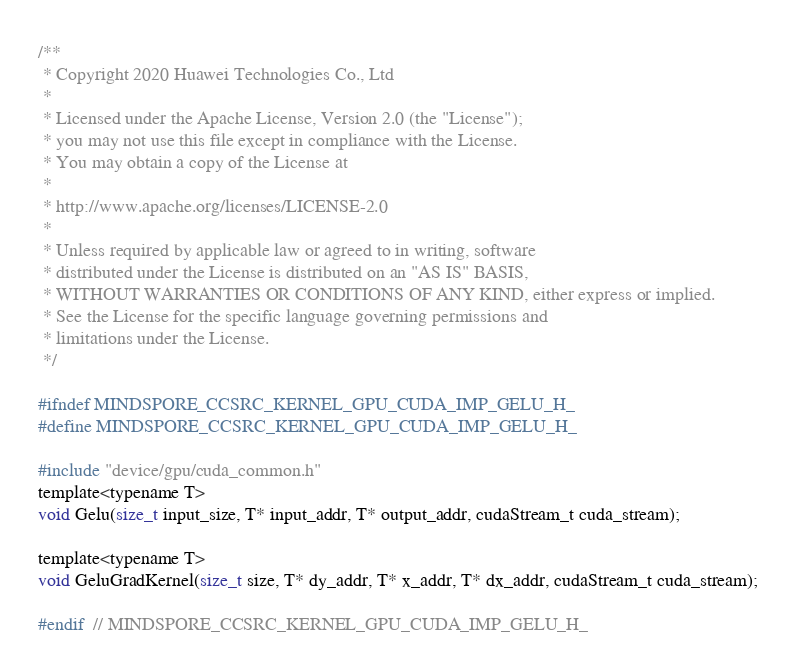Convert code to text. <code><loc_0><loc_0><loc_500><loc_500><_Cuda_>/**
 * Copyright 2020 Huawei Technologies Co., Ltd
 *
 * Licensed under the Apache License, Version 2.0 (the "License");
 * you may not use this file except in compliance with the License.
 * You may obtain a copy of the License at
 *
 * http://www.apache.org/licenses/LICENSE-2.0
 *
 * Unless required by applicable law or agreed to in writing, software
 * distributed under the License is distributed on an "AS IS" BASIS,
 * WITHOUT WARRANTIES OR CONDITIONS OF ANY KIND, either express or implied.
 * See the License for the specific language governing permissions and
 * limitations under the License.
 */

#ifndef MINDSPORE_CCSRC_KERNEL_GPU_CUDA_IMP_GELU_H_
#define MINDSPORE_CCSRC_KERNEL_GPU_CUDA_IMP_GELU_H_

#include "device/gpu/cuda_common.h"
template<typename T>
void Gelu(size_t input_size, T* input_addr, T* output_addr, cudaStream_t cuda_stream);

template<typename T>
void GeluGradKernel(size_t size, T* dy_addr, T* x_addr, T* dx_addr, cudaStream_t cuda_stream);

#endif  // MINDSPORE_CCSRC_KERNEL_GPU_CUDA_IMP_GELU_H_
</code> 